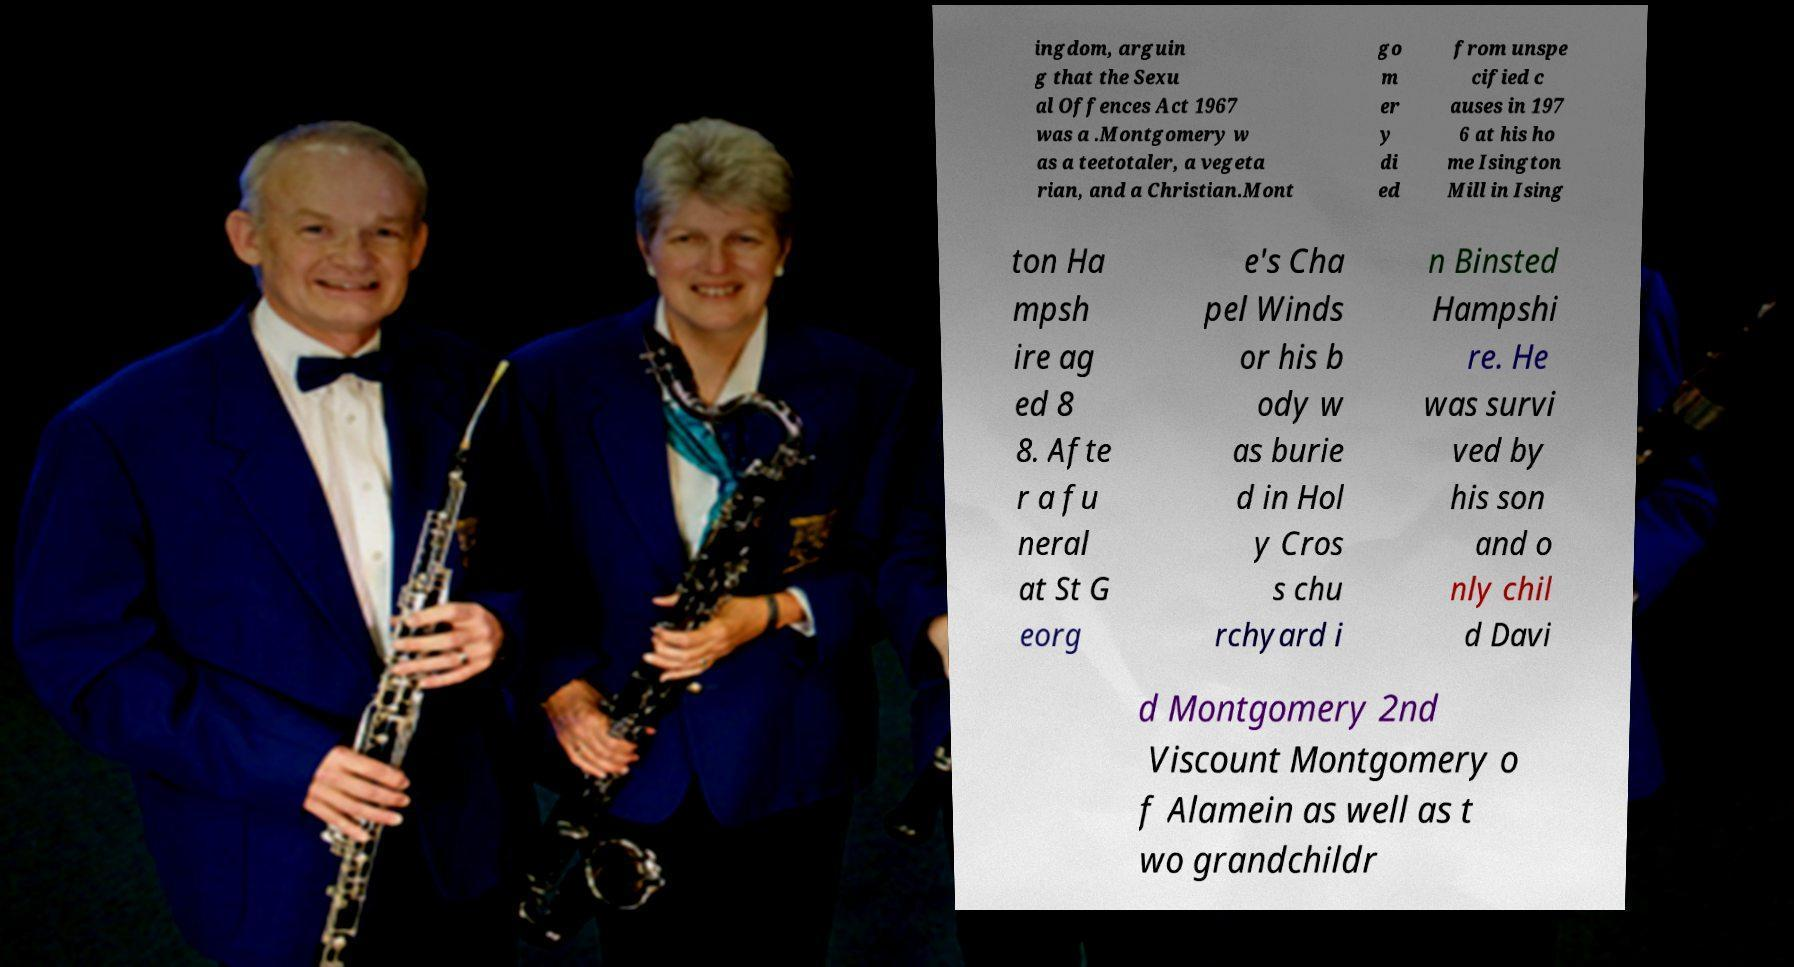What messages or text are displayed in this image? I need them in a readable, typed format. ingdom, arguin g that the Sexu al Offences Act 1967 was a .Montgomery w as a teetotaler, a vegeta rian, and a Christian.Mont go m er y di ed from unspe cified c auses in 197 6 at his ho me Isington Mill in Ising ton Ha mpsh ire ag ed 8 8. Afte r a fu neral at St G eorg e's Cha pel Winds or his b ody w as burie d in Hol y Cros s chu rchyard i n Binsted Hampshi re. He was survi ved by his son and o nly chil d Davi d Montgomery 2nd Viscount Montgomery o f Alamein as well as t wo grandchildr 